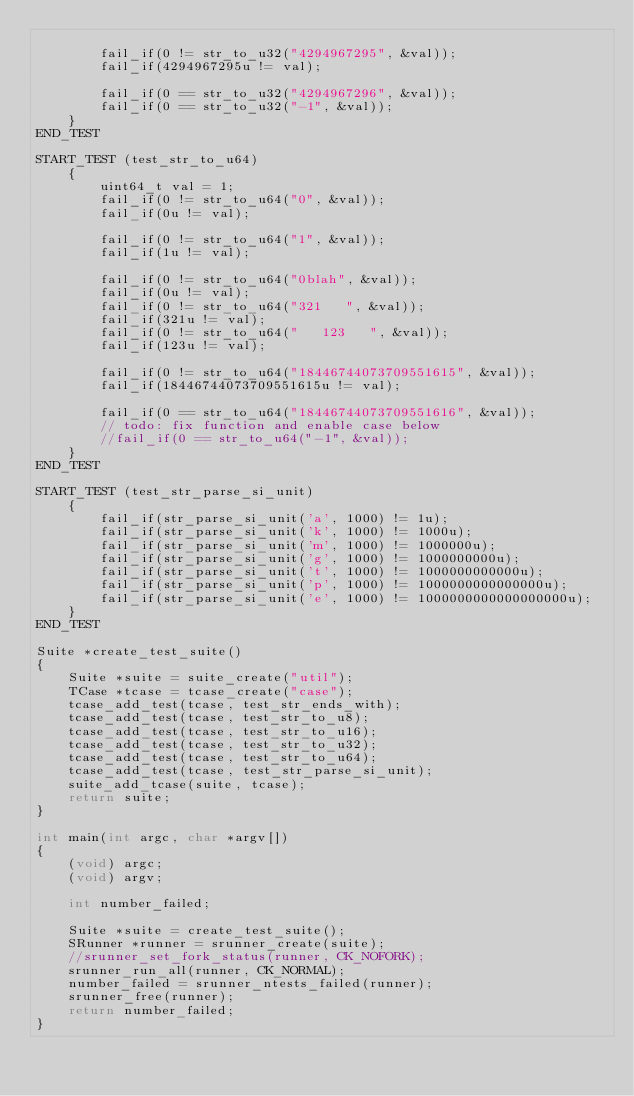Convert code to text. <code><loc_0><loc_0><loc_500><loc_500><_C_>
        fail_if(0 != str_to_u32("4294967295", &val));
        fail_if(4294967295u != val);

        fail_if(0 == str_to_u32("4294967296", &val));
        fail_if(0 == str_to_u32("-1", &val));
    }
END_TEST

START_TEST (test_str_to_u64)
    {
        uint64_t val = 1;
        fail_if(0 != str_to_u64("0", &val));
        fail_if(0u != val);

        fail_if(0 != str_to_u64("1", &val));
        fail_if(1u != val);

        fail_if(0 != str_to_u64("0blah", &val));
        fail_if(0u != val);
        fail_if(0 != str_to_u64("321   ", &val));
        fail_if(321u != val);
        fail_if(0 != str_to_u64("   123   ", &val));
        fail_if(123u != val);

        fail_if(0 != str_to_u64("18446744073709551615", &val));
        fail_if(18446744073709551615u != val);

        fail_if(0 == str_to_u64("18446744073709551616", &val));
        // todo: fix function and enable case below
        //fail_if(0 == str_to_u64("-1", &val));
    }
END_TEST

START_TEST (test_str_parse_si_unit)
    {
        fail_if(str_parse_si_unit('a', 1000) != 1u);
        fail_if(str_parse_si_unit('k', 1000) != 1000u);
        fail_if(str_parse_si_unit('m', 1000) != 1000000u);
        fail_if(str_parse_si_unit('g', 1000) != 1000000000u);
        fail_if(str_parse_si_unit('t', 1000) != 1000000000000u);
        fail_if(str_parse_si_unit('p', 1000) != 1000000000000000u);
        fail_if(str_parse_si_unit('e', 1000) != 1000000000000000000u);
    }
END_TEST

Suite *create_test_suite()
{
    Suite *suite = suite_create("util");
    TCase *tcase = tcase_create("case");
    tcase_add_test(tcase, test_str_ends_with);
    tcase_add_test(tcase, test_str_to_u8);
    tcase_add_test(tcase, test_str_to_u16);
    tcase_add_test(tcase, test_str_to_u32);
    tcase_add_test(tcase, test_str_to_u64);
    tcase_add_test(tcase, test_str_parse_si_unit);
    suite_add_tcase(suite, tcase);
    return suite;
}

int main(int argc, char *argv[])
{
    (void) argc;
    (void) argv;

    int number_failed;

    Suite *suite = create_test_suite();
    SRunner *runner = srunner_create(suite);
    //srunner_set_fork_status(runner, CK_NOFORK);
    srunner_run_all(runner, CK_NORMAL);
    number_failed = srunner_ntests_failed(runner);
    srunner_free(runner);
    return number_failed;
}
</code> 